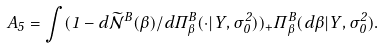Convert formula to latex. <formula><loc_0><loc_0><loc_500><loc_500>A _ { 5 } = \int ( 1 - d \widetilde { \mathcal { N } } ^ { B } ( \beta ) / d \Pi _ { \beta } ^ { B } ( \cdot | Y , \sigma _ { 0 } ^ { 2 } ) ) _ { + } \Pi _ { \beta } ^ { B } ( d \beta | Y , \sigma _ { 0 } ^ { 2 } ) .</formula> 